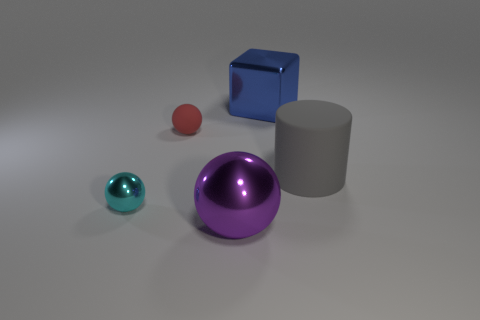Add 4 cubes. How many objects exist? 9 Subtract all big balls. How many balls are left? 2 Subtract all red balls. How many balls are left? 2 Subtract all cubes. How many objects are left? 4 Subtract 1 balls. How many balls are left? 2 Subtract all yellow cubes. Subtract all blue cylinders. How many cubes are left? 1 Subtract all cyan balls. Subtract all large cubes. How many objects are left? 3 Add 5 rubber objects. How many rubber objects are left? 7 Add 5 small brown blocks. How many small brown blocks exist? 5 Subtract 0 red cylinders. How many objects are left? 5 